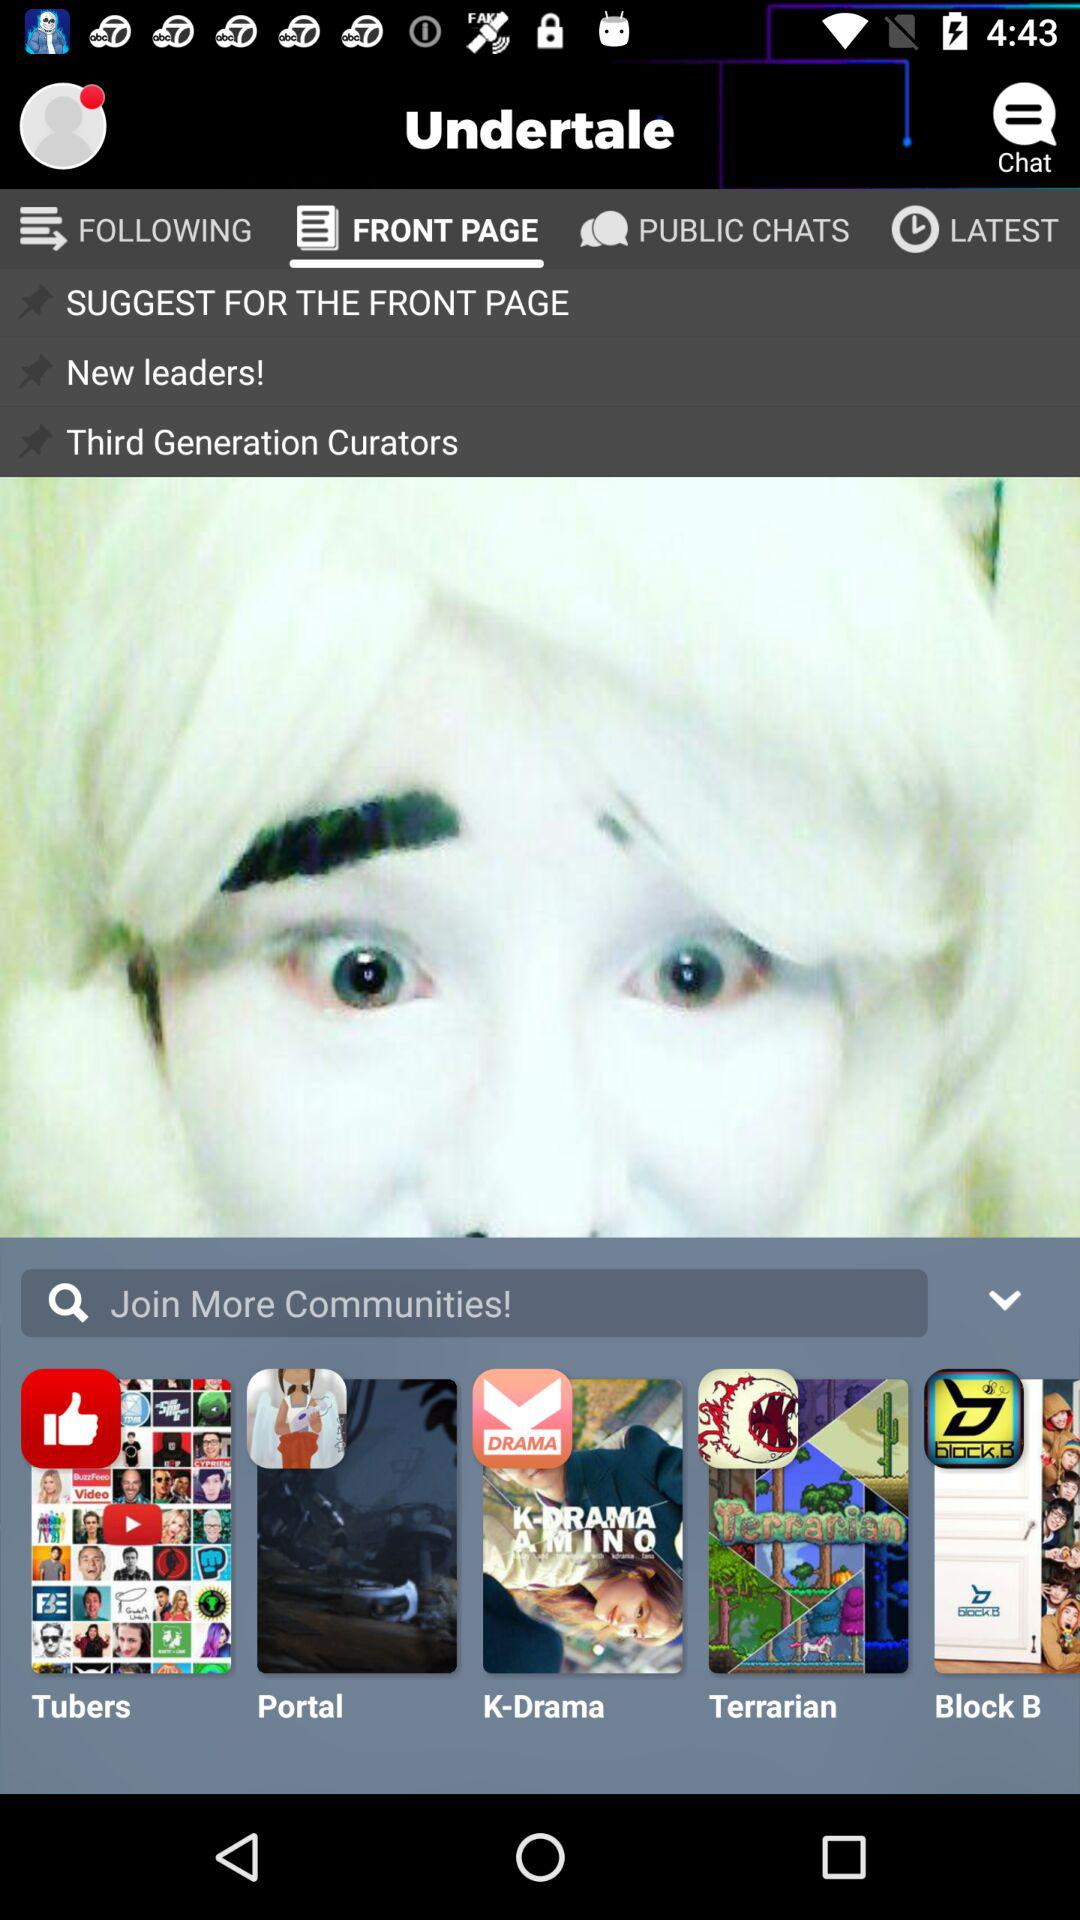Which tab is selected? The selected tab is "FRONT PAGE". 